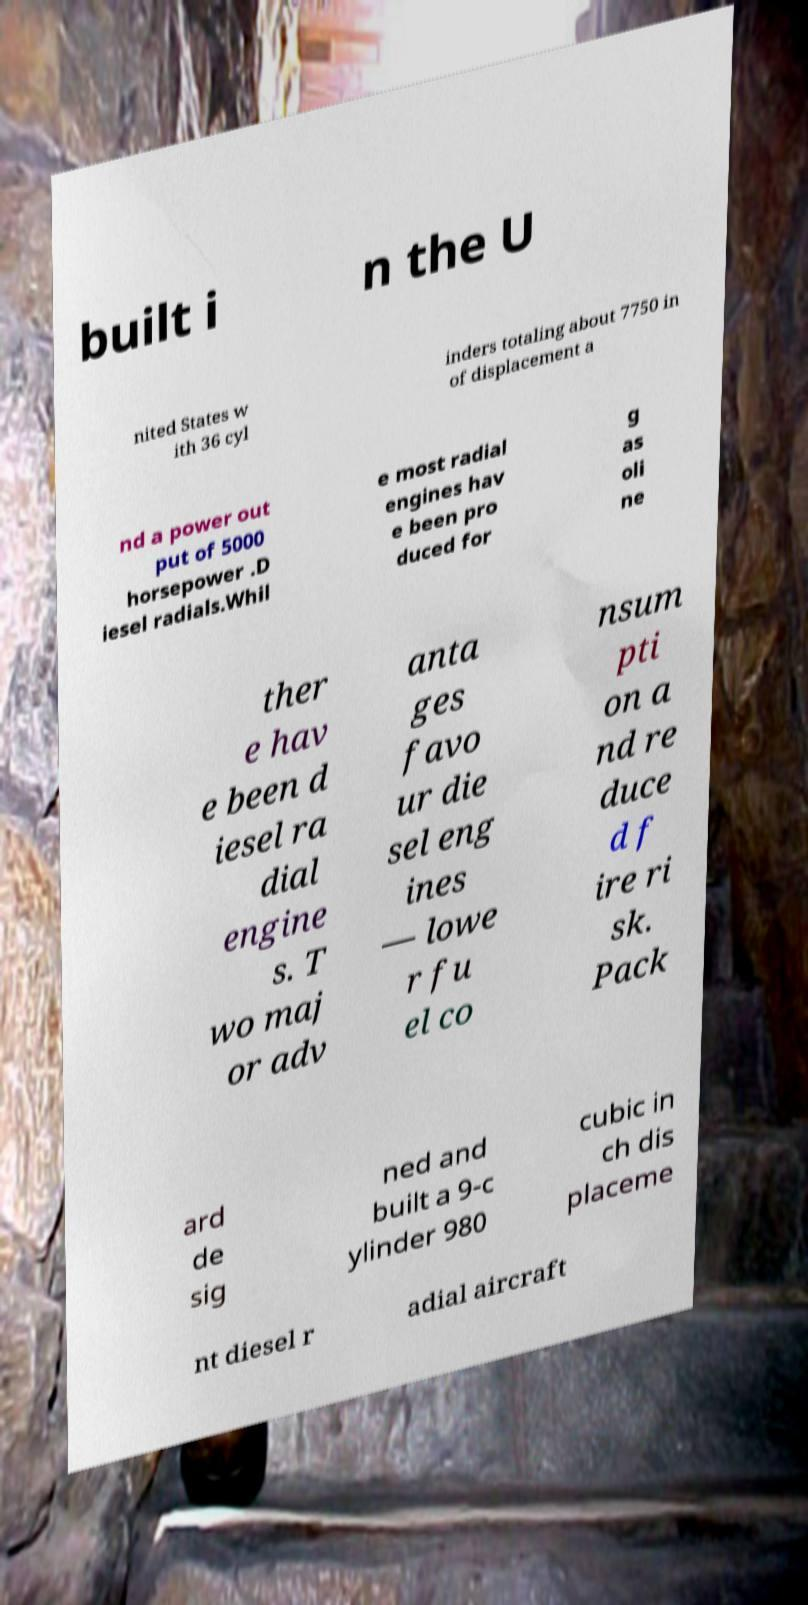Please identify and transcribe the text found in this image. built i n the U nited States w ith 36 cyl inders totaling about 7750 in of displacement a nd a power out put of 5000 horsepower .D iesel radials.Whil e most radial engines hav e been pro duced for g as oli ne ther e hav e been d iesel ra dial engine s. T wo maj or adv anta ges favo ur die sel eng ines — lowe r fu el co nsum pti on a nd re duce d f ire ri sk. Pack ard de sig ned and built a 9-c ylinder 980 cubic in ch dis placeme nt diesel r adial aircraft 